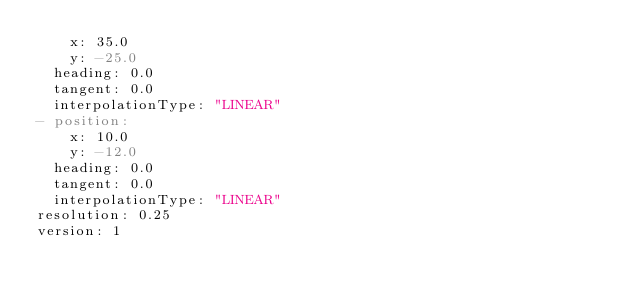<code> <loc_0><loc_0><loc_500><loc_500><_YAML_>    x: 35.0
    y: -25.0
  heading: 0.0
  tangent: 0.0
  interpolationType: "LINEAR"
- position:
    x: 10.0
    y: -12.0
  heading: 0.0
  tangent: 0.0
  interpolationType: "LINEAR"
resolution: 0.25
version: 1
</code> 